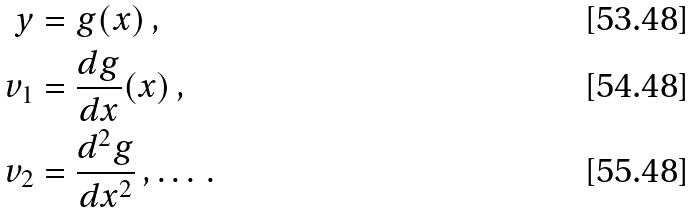<formula> <loc_0><loc_0><loc_500><loc_500>y & = g ( x ) \, , \\ v _ { 1 } & = \frac { d g } { d x } ( x ) \, , \\ v _ { 2 } & = \frac { d ^ { 2 } g } { d x ^ { 2 } } \, , \dots \, .</formula> 